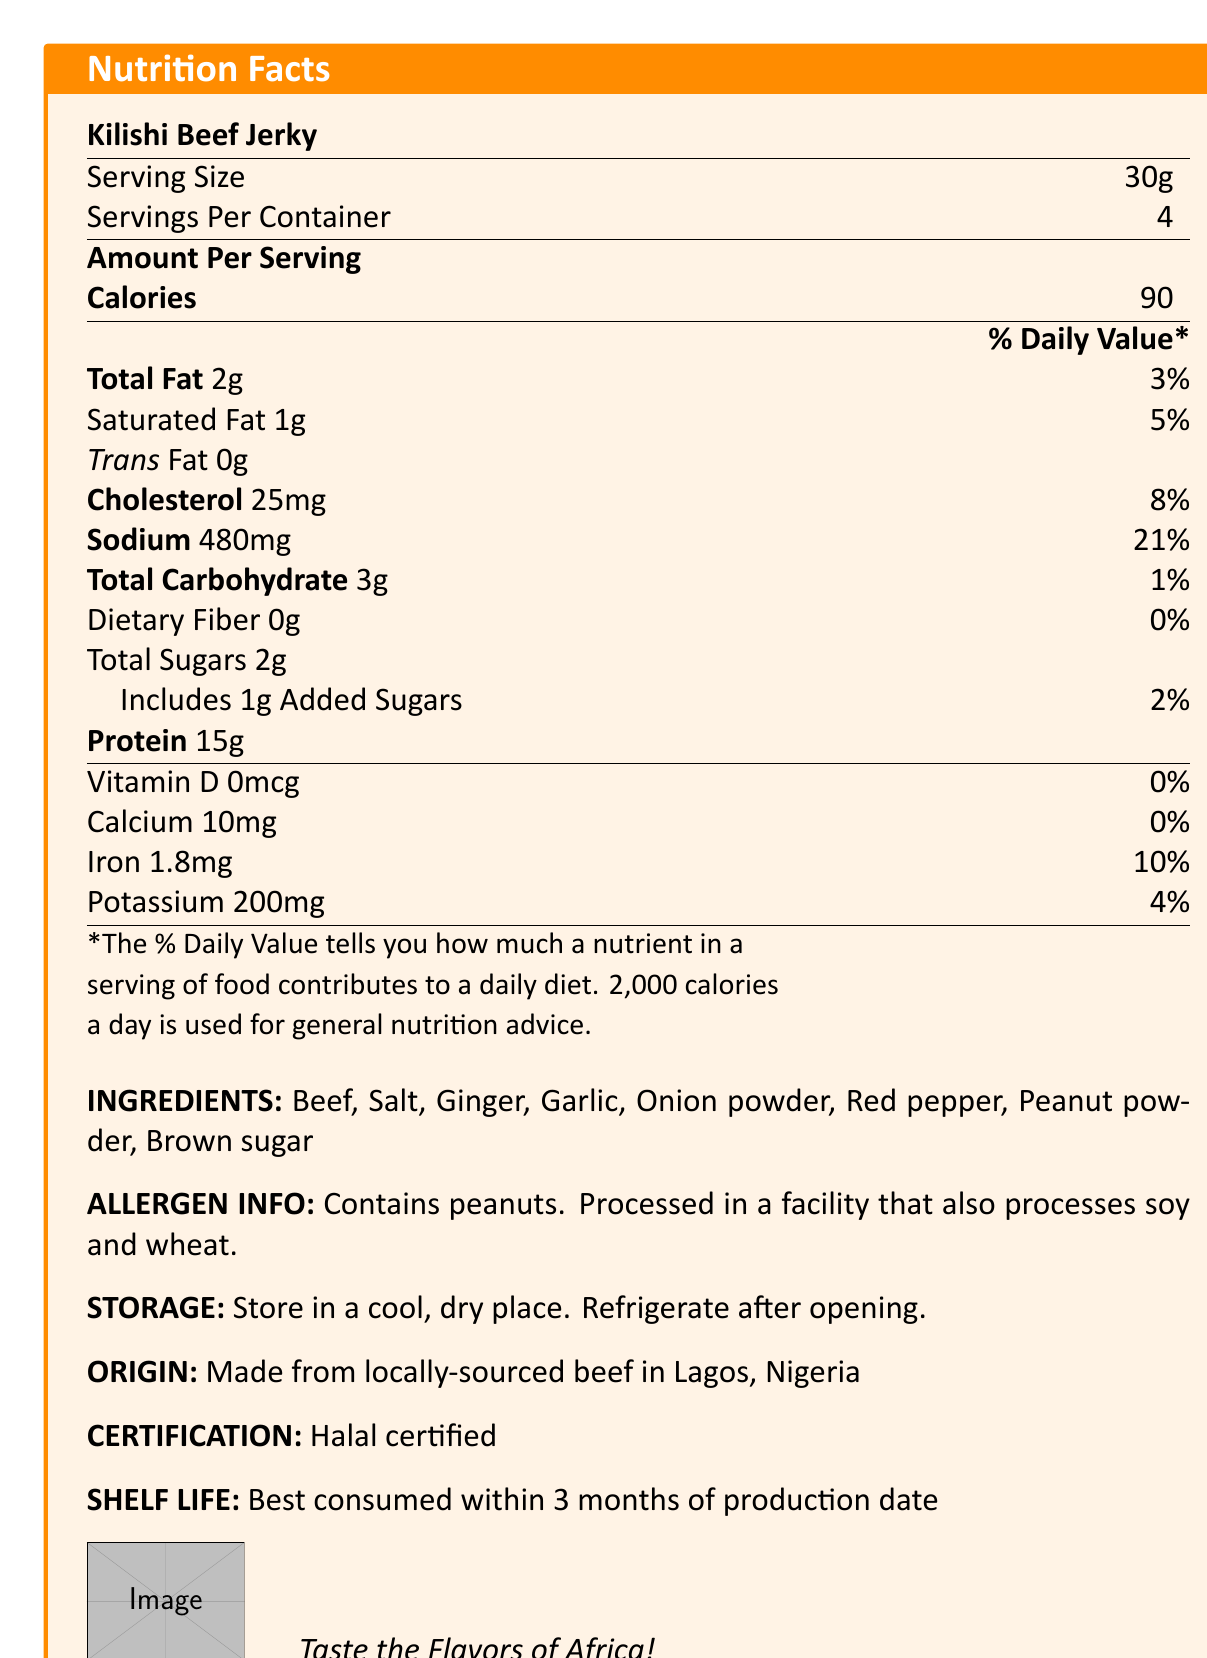what is the serving size of Kilishi Beef Jerky? The document clearly states the serving size as 30g.
Answer: 30g how many servings per container are there? According to the document, there are 4 servings per container.
Answer: 4 what is the total fat content per serving? The total fat content per serving is listed as 2g.
Answer: 2g how much protein is in one serving of Kilishi Beef Jerky? The document specifies that there are 15g of protein per serving.
Answer: 15g what is the sodium content per serving in milligrams? The sodium content per serving is stated as 480mg in the document.
Answer: 480mg how much iron is in a serving? A. 0.5mg B. 1.8mg C. 3.0mg D. 5.0mg The document lists the iron content per serving as 1.8mg.
Answer: B. 1.8mg how many grams of saturated fat are there in one serving? A. 0g B. 0.5g C. 1g D. 2g The saturated fat content per serving is 1g, as indicated in the document.
Answer: C. 1g is the product Halal certified? The document explicitly mentions that the product is Halal certified.
Answer: Yes does the product contain any dietary fiber? The nutritional facts indicate that the dietary fiber per serving is 0g.
Answer: No describe the main idea of the document. The document is structured to give a comprehensive overview of the nutritional value, ingredients, and other important details about Kilishi Beef Jerky, allowing consumers to make informed choices.
Answer: The document provides detailed nutritional facts about Kilishi Beef Jerky, including serving size, calorie count, macronutritional content, and vitamin and mineral information. It includes ingredient and allergen information, storage instructions, origin, certification, and shelf life. what percentage of the daily value for sodium does one serving provide? The document shows that one serving provides 21% of the daily value for sodium.
Answer: 21% how long is the shelf life of Kilishi Beef Jerky? The document advises that the product is best consumed within 3 months of the production date.
Answer: Best consumed within 3 months of production date what is the total carbohydrate content per serving? The total carbohydrate content per serving is listed as 3g in the document.
Answer: 3g how much calcium is present in one serving? The document indicates that there are 10mg of calcium per serving.
Answer: 10mg how should the product be stored after opening? The storage instructions state that the product should be refrigerated after opening.
Answer: Refrigerate after opening is the product made from locally-sourced beef in Accra, Ghana? The document states that the product is made from locally-sourced beef in Lagos, Nigeria.
Answer: No what are the ingredients in Kilishi Beef Jerky? The document lists these ingredients explicitly.
Answer: Beef, Salt, Ginger, Garlic, Onion powder, Red pepper, Peanut powder, Brown sugar does the product contain any added sugars? The document specifies that each serving includes 1g of added sugars.
Answer: Yes what vitamins are present in the product? The document lists Vitamin D as 0mcg, indicating no measurable vitamins.
Answer: None what is the daily value percentage of iron per serving? The document indicates that one serving provides 10% of the daily value for iron.
Answer: 10% which of the following allergens does the product contain? A. Soy B. Wheat C. Milk D. Peanuts The document states that the product contains peanuts and it is processed in a facility that also processes soy and wheat.
Answer: D. Peanuts what kind of place should the product be stored in before opening? The storage instructions recommend keeping the product in a cool, dry place before opening.
Answer: Store in a cool, dry place how many calories are there in one serving? The document provides the calorie count per serving as 90.
Answer: 90 can the shelf life of the product be extended beyond 3 months by freezing? The document only states the shelf life as best consumed within 3 months of the production date, without mentioning freezing as an option.
Answer: Cannot be determined what type of certification does Kilishi Beef Jerky have? The document clearly states that the product is Halal certified.
Answer: Halal certified 